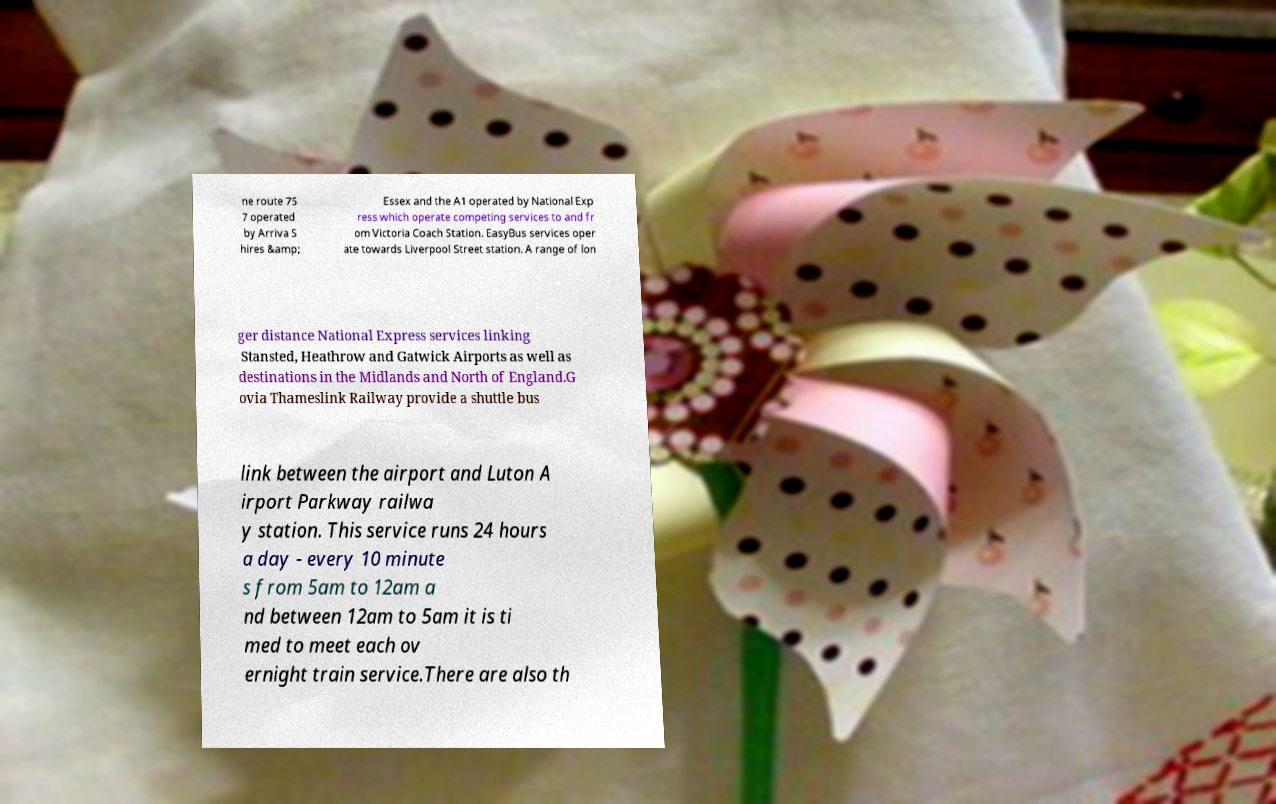Can you accurately transcribe the text from the provided image for me? ne route 75 7 operated by Arriva S hires &amp; Essex and the A1 operated by National Exp ress which operate competing services to and fr om Victoria Coach Station. EasyBus services oper ate towards Liverpool Street station. A range of lon ger distance National Express services linking Stansted, Heathrow and Gatwick Airports as well as destinations in the Midlands and North of England.G ovia Thameslink Railway provide a shuttle bus link between the airport and Luton A irport Parkway railwa y station. This service runs 24 hours a day - every 10 minute s from 5am to 12am a nd between 12am to 5am it is ti med to meet each ov ernight train service.There are also th 